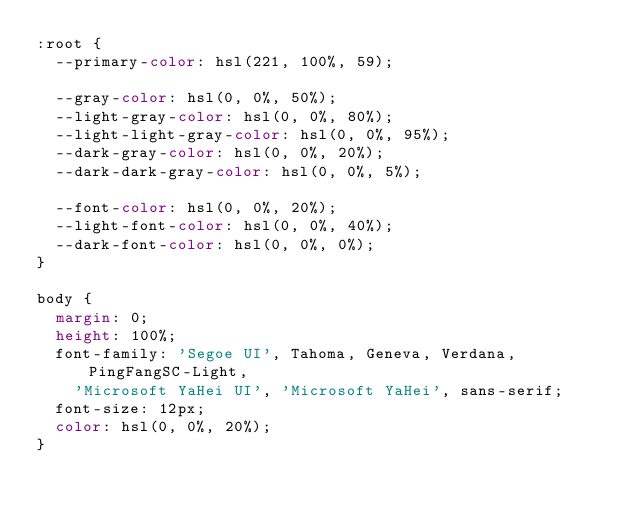Convert code to text. <code><loc_0><loc_0><loc_500><loc_500><_CSS_>:root {
  --primary-color: hsl(221, 100%, 59);

  --gray-color: hsl(0, 0%, 50%);
  --light-gray-color: hsl(0, 0%, 80%);
  --light-light-gray-color: hsl(0, 0%, 95%);
  --dark-gray-color: hsl(0, 0%, 20%);
  --dark-dark-gray-color: hsl(0, 0%, 5%);

  --font-color: hsl(0, 0%, 20%);
  --light-font-color: hsl(0, 0%, 40%);
  --dark-font-color: hsl(0, 0%, 0%);
}

body {
  margin: 0;
  height: 100%;
  font-family: 'Segoe UI', Tahoma, Geneva, Verdana, PingFangSC-Light,
    'Microsoft YaHei UI', 'Microsoft YaHei', sans-serif;
  font-size: 12px;
  color: hsl(0, 0%, 20%);
}
</code> 